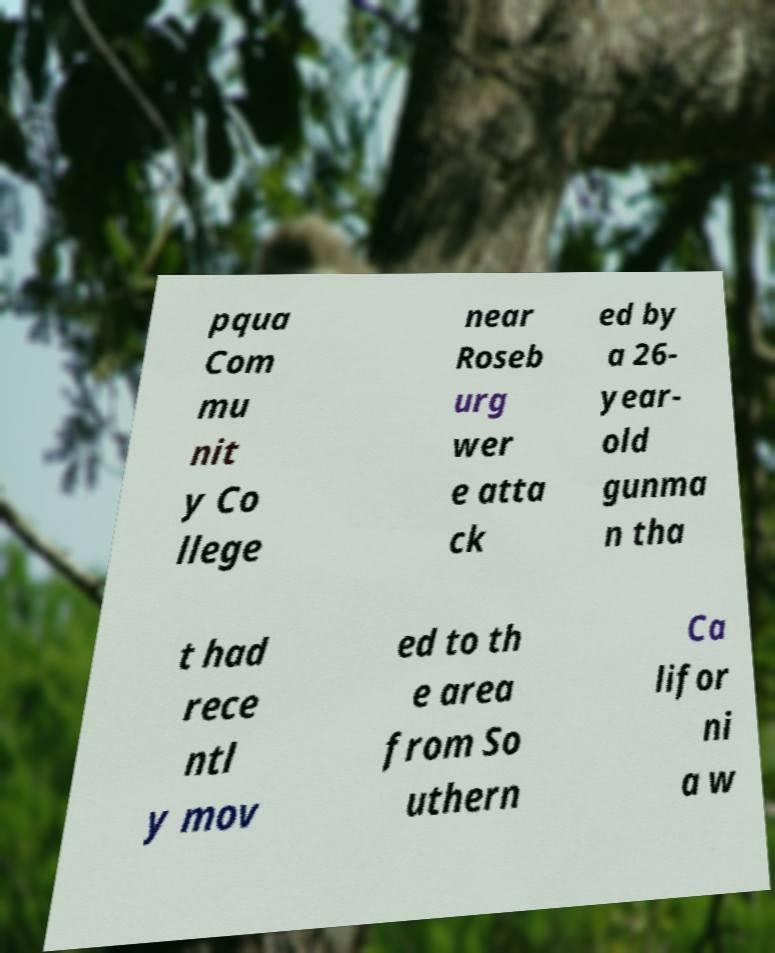For documentation purposes, I need the text within this image transcribed. Could you provide that? pqua Com mu nit y Co llege near Roseb urg wer e atta ck ed by a 26- year- old gunma n tha t had rece ntl y mov ed to th e area from So uthern Ca lifor ni a w 